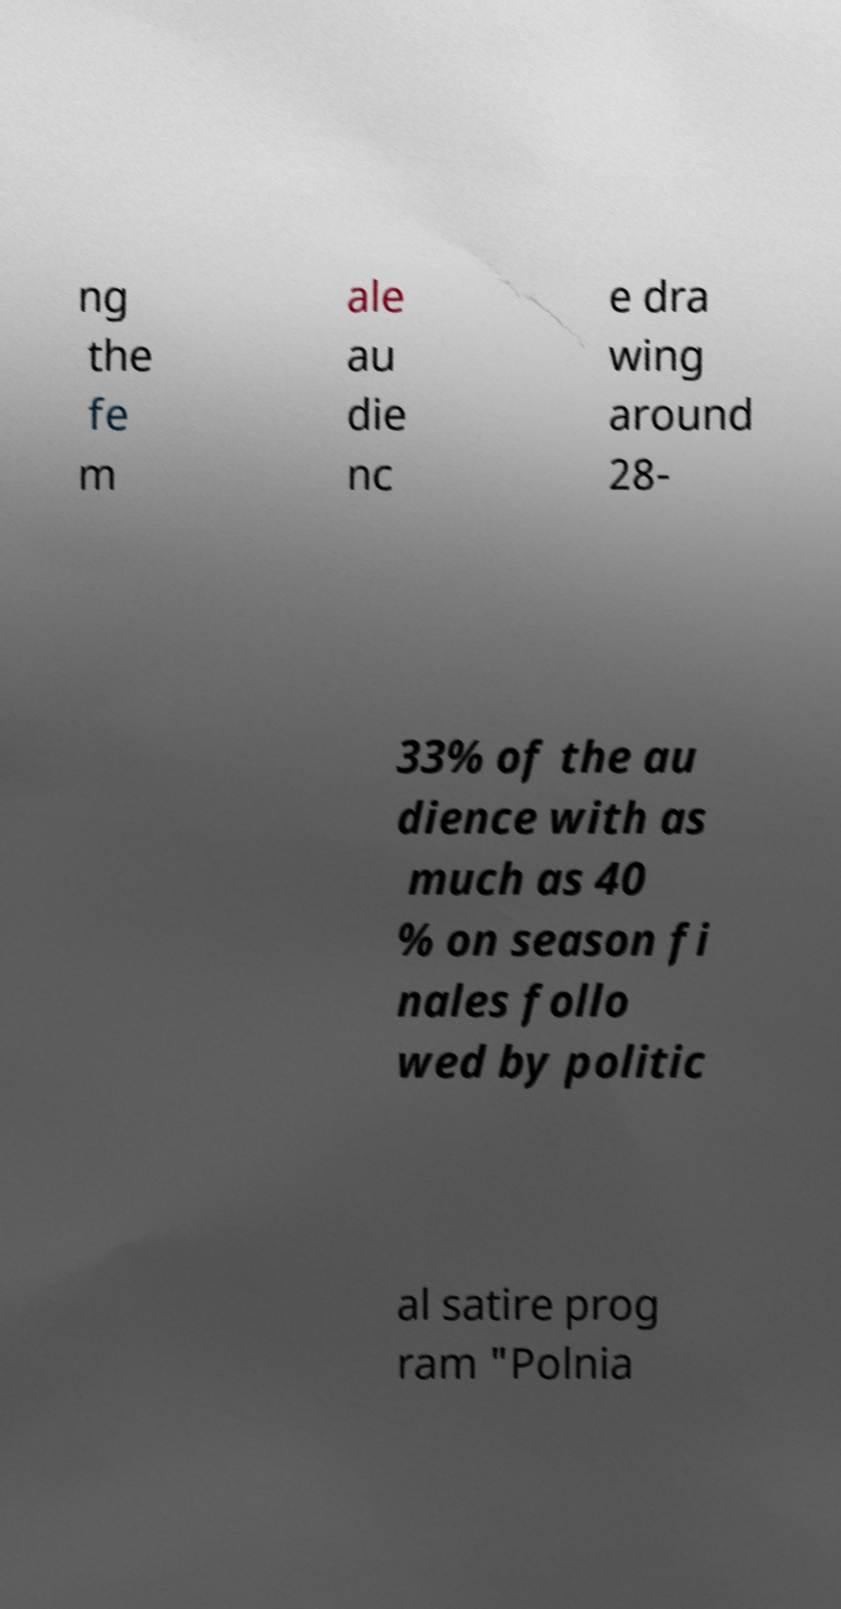What messages or text are displayed in this image? I need them in a readable, typed format. ng the fe m ale au die nc e dra wing around 28- 33% of the au dience with as much as 40 % on season fi nales follo wed by politic al satire prog ram "Polnia 